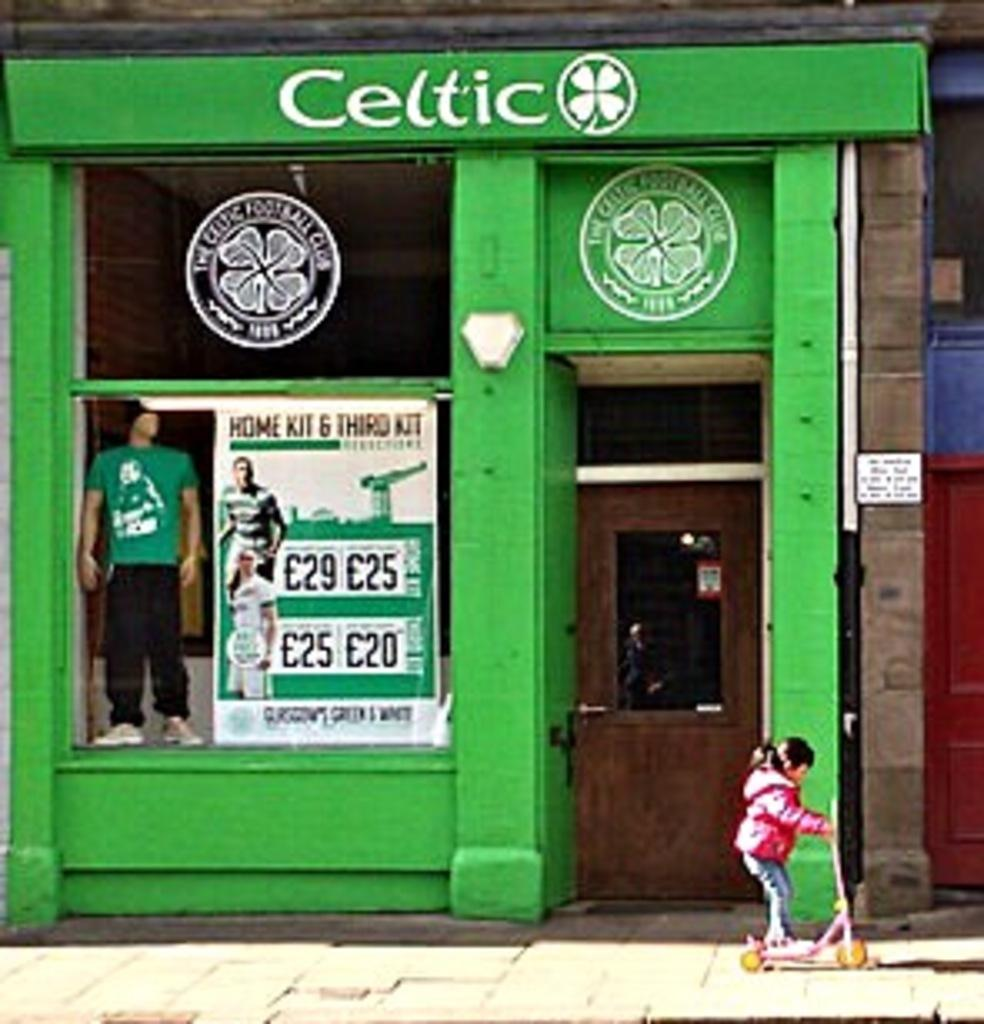<image>
Present a compact description of the photo's key features. A green storefront building that says Celtic on the top of it. 